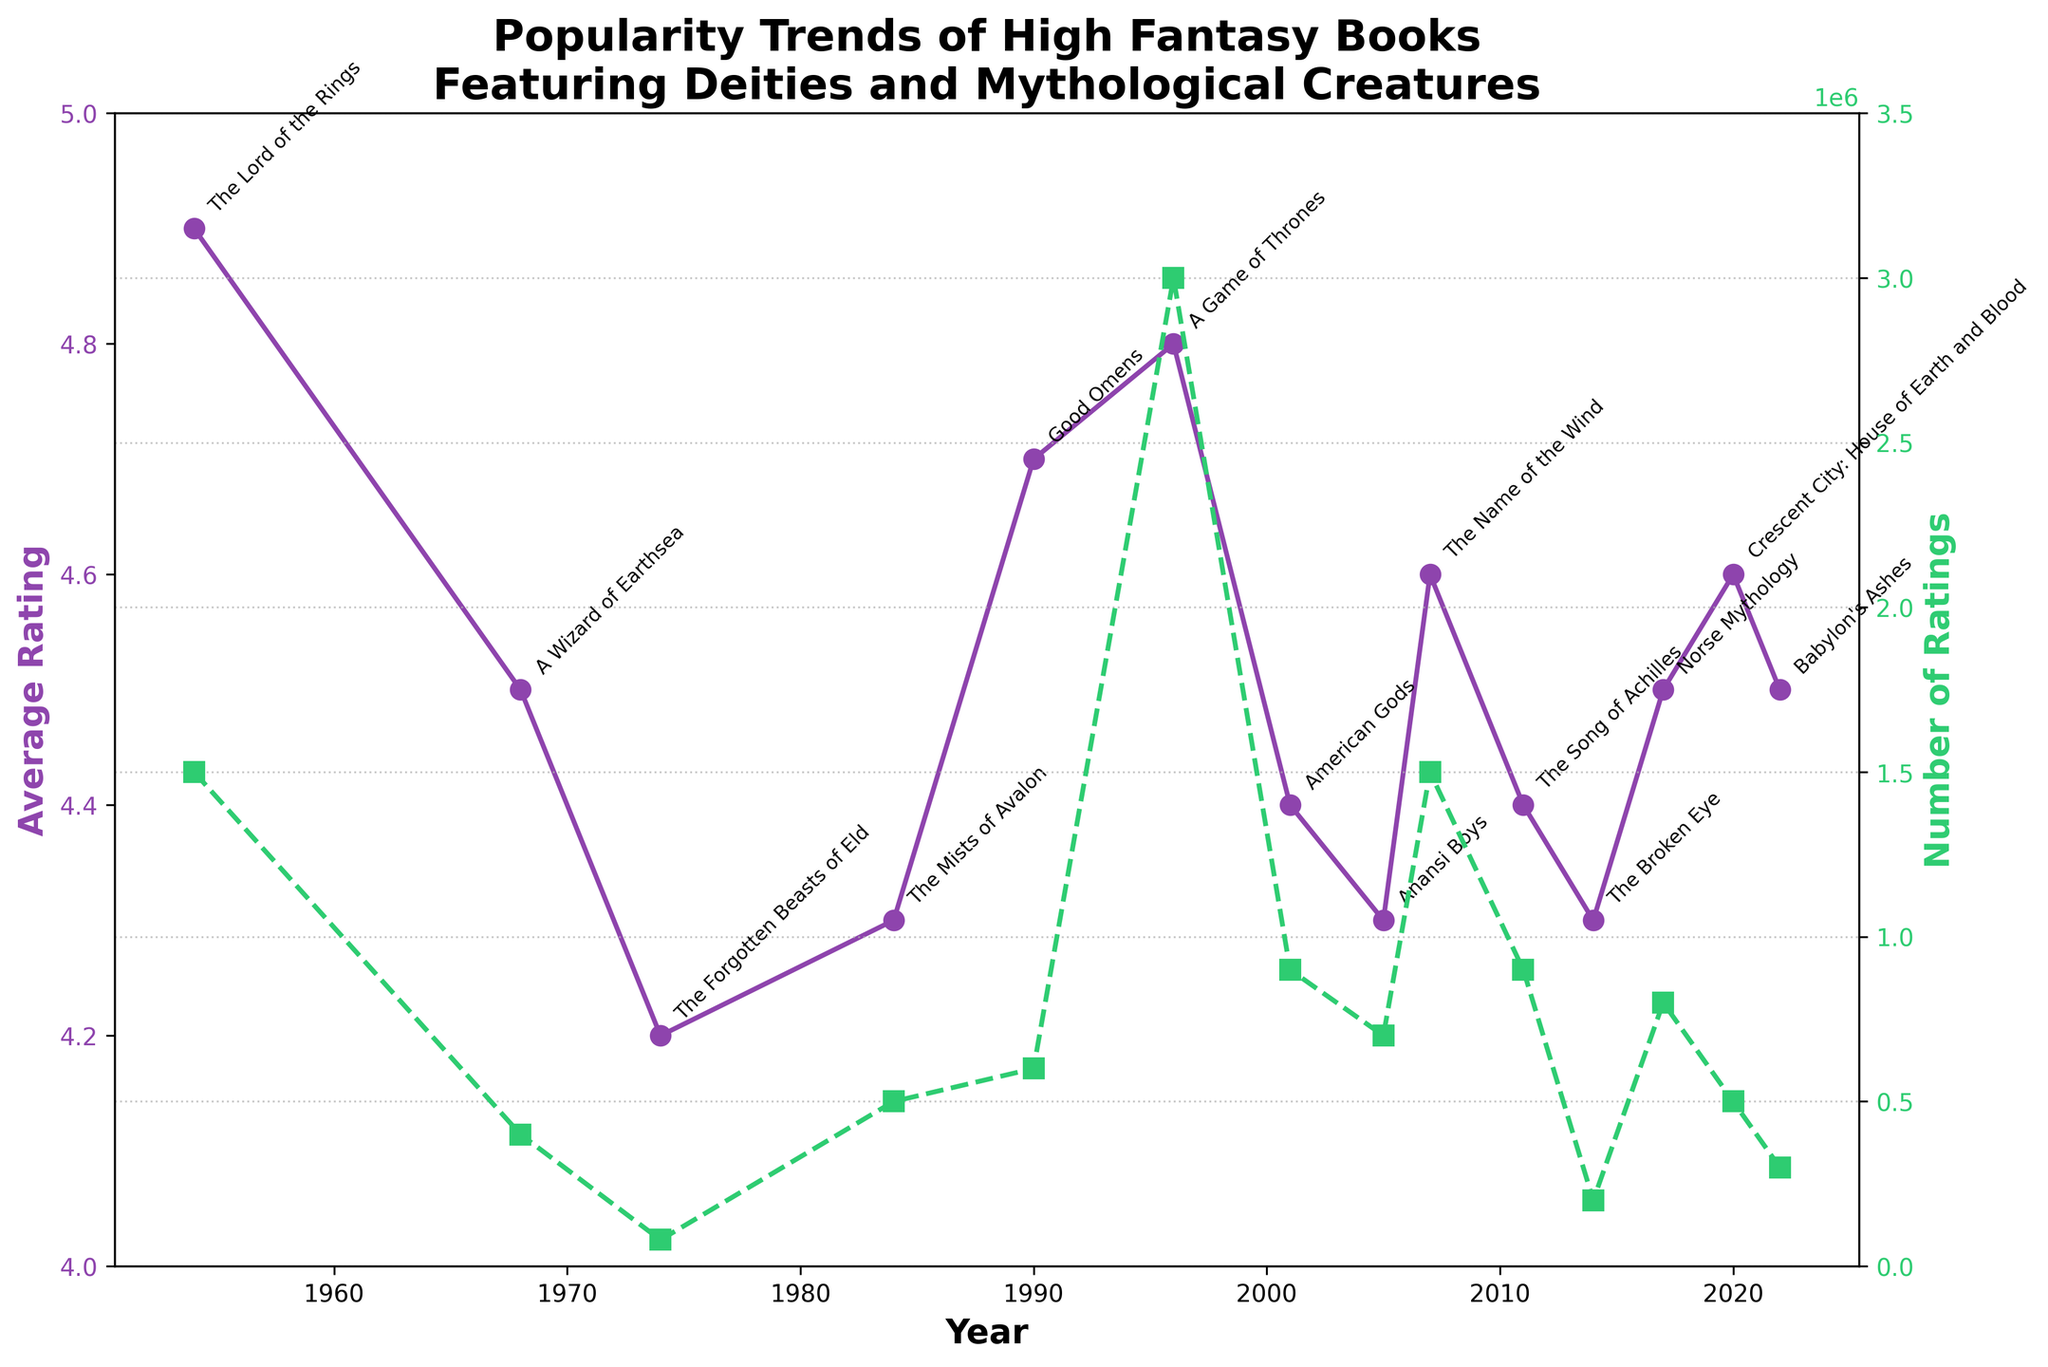What's the title of the plot? The title is displayed at the top of the plot in bold and larger font size. It reads "Popularity Trends of High Fantasy Books Featuring Deities and Mythological Creatures".
Answer: Popularity Trends of High Fantasy Books Featuring Deities and Mythological Creatures What rating does "The Lord of the Rings" have? By locating "The Lord of the Rings" in the annotations on the plot and following its corresponding vertical marker line on the left y-axis, it is observed to be at 4.9.
Answer: 4.9 Which book has the highest number of ratings? The number of ratings is displayed on the right y-axis. "A Game of Thrones" is the peak point on this axis, indicating approximately 3,000,000 ratings.
Answer: A Game of Thrones How does the average rating trend from 1950 to the present? By examining the left y-axis and following the purple line from 1950 to the present, the average rating remains consistently high, ranging from about 4.2 to 4.9.
Answer: Consistently high Compare the number of ratings for "American Gods" and "Anansi Boys". "American Gods" appears on the plot with a number of ratings around 900,000, while "Anansi Boys" is marked at about 700,000. These values can be directly compared from the green line on the right y-axis.
Answer: American Gods has more ratings Which book witnessed the highest average rating among those published after 2000? Books published after 2000 can be identified, and their ratings can be compared using the left y-axis. "The Name of the Wind" (2007) holds the highest rating among these, at about 4.6.
Answer: The Name of the Wind What is the trend in the number of ratings from "The Lord of the Rings" to "Babylon's Ashes"? Observing the number of ratings from the green dashed line, we see a generally increasing trend reaching a peak with "A Game of Thrones" in 1996, before a gradual decline towads 2022 with "Babylon's Ashes".
Answer: Increasing then decreasing Did any book after 1990 achieve an average rating below 4.5? By checking the annotations and following the purple line on the left y-axis, both "The Forgotten Beasts of Eld" (4.2) and "The Mists of Avalon" (4.3) have ratings below 4.5 after 1990.
Answer: Yes, several Which year saw the highest number of book ratings and what was the book? By identifying the highest peak on the right y-axis, 1996 is evident as the year with the highest number of ratings, corresponding to "A Game of Thrones".
Answer: 1996, A Game of Thrones 